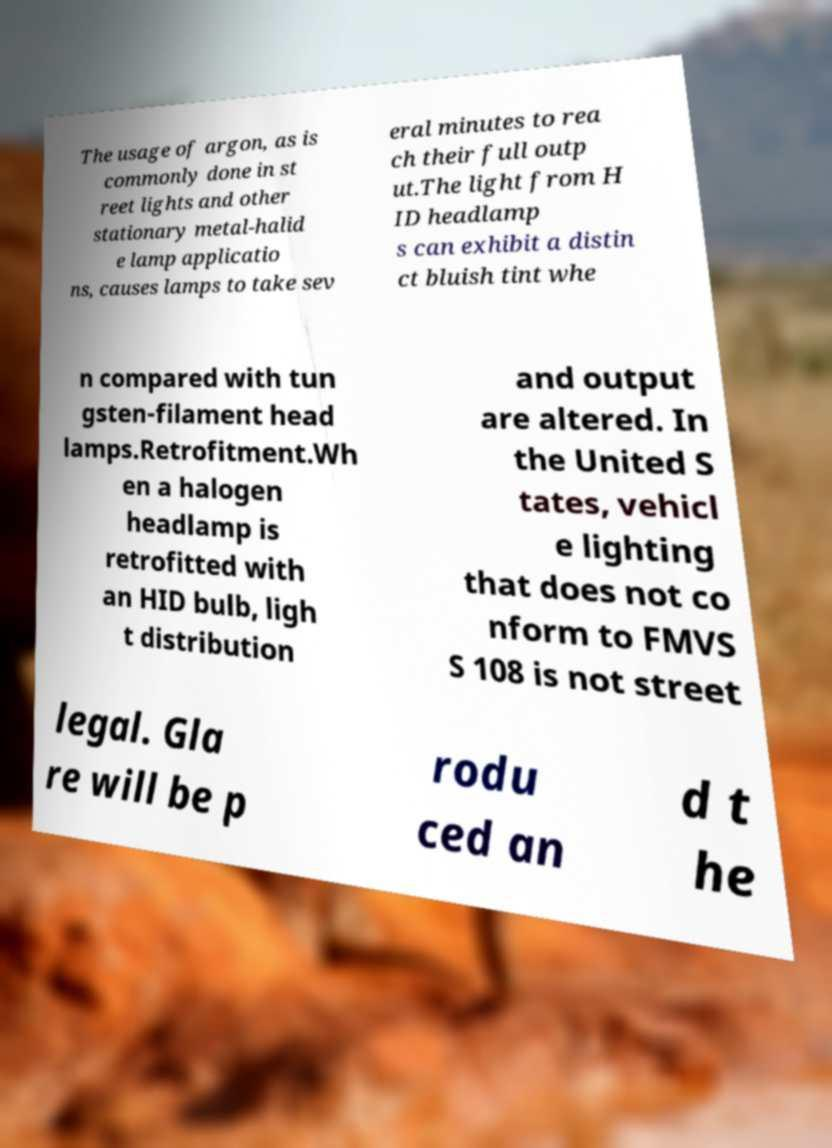What messages or text are displayed in this image? I need them in a readable, typed format. The usage of argon, as is commonly done in st reet lights and other stationary metal-halid e lamp applicatio ns, causes lamps to take sev eral minutes to rea ch their full outp ut.The light from H ID headlamp s can exhibit a distin ct bluish tint whe n compared with tun gsten-filament head lamps.Retrofitment.Wh en a halogen headlamp is retrofitted with an HID bulb, ligh t distribution and output are altered. In the United S tates, vehicl e lighting that does not co nform to FMVS S 108 is not street legal. Gla re will be p rodu ced an d t he 